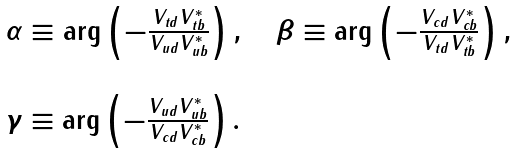<formula> <loc_0><loc_0><loc_500><loc_500>\begin{array} { l } \alpha \equiv \arg \left ( - \frac { V _ { t d } V _ { t b } ^ { * } } { V _ { u d } V _ { u b } ^ { * } } \right ) , \quad \beta \equiv \arg \left ( - \frac { V _ { c d } V _ { c b } ^ { * } } { V _ { t d } V _ { t b } ^ { * } } \right ) , \\ \\ \gamma \equiv \arg \left ( - \frac { V _ { u d } V _ { u b } ^ { * } } { V _ { c d } V _ { c b } ^ { * } } \right ) . \end{array}</formula> 